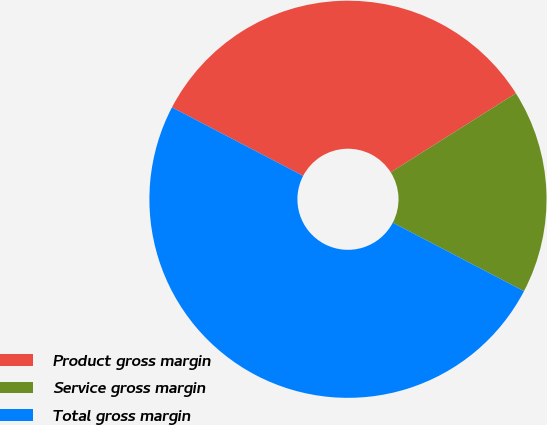Convert chart to OTSL. <chart><loc_0><loc_0><loc_500><loc_500><pie_chart><fcel>Product gross margin<fcel>Service gross margin<fcel>Total gross margin<nl><fcel>33.38%<fcel>16.62%<fcel>50.0%<nl></chart> 